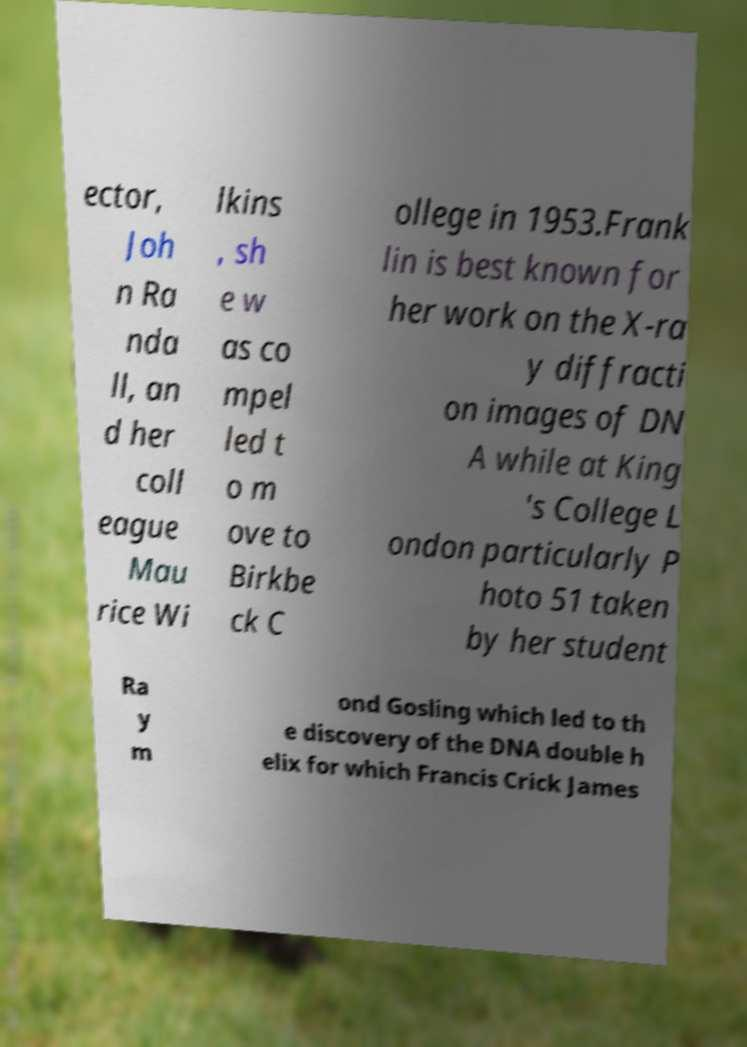Please identify and transcribe the text found in this image. ector, Joh n Ra nda ll, an d her coll eague Mau rice Wi lkins , sh e w as co mpel led t o m ove to Birkbe ck C ollege in 1953.Frank lin is best known for her work on the X-ra y diffracti on images of DN A while at King 's College L ondon particularly P hoto 51 taken by her student Ra y m ond Gosling which led to th e discovery of the DNA double h elix for which Francis Crick James 